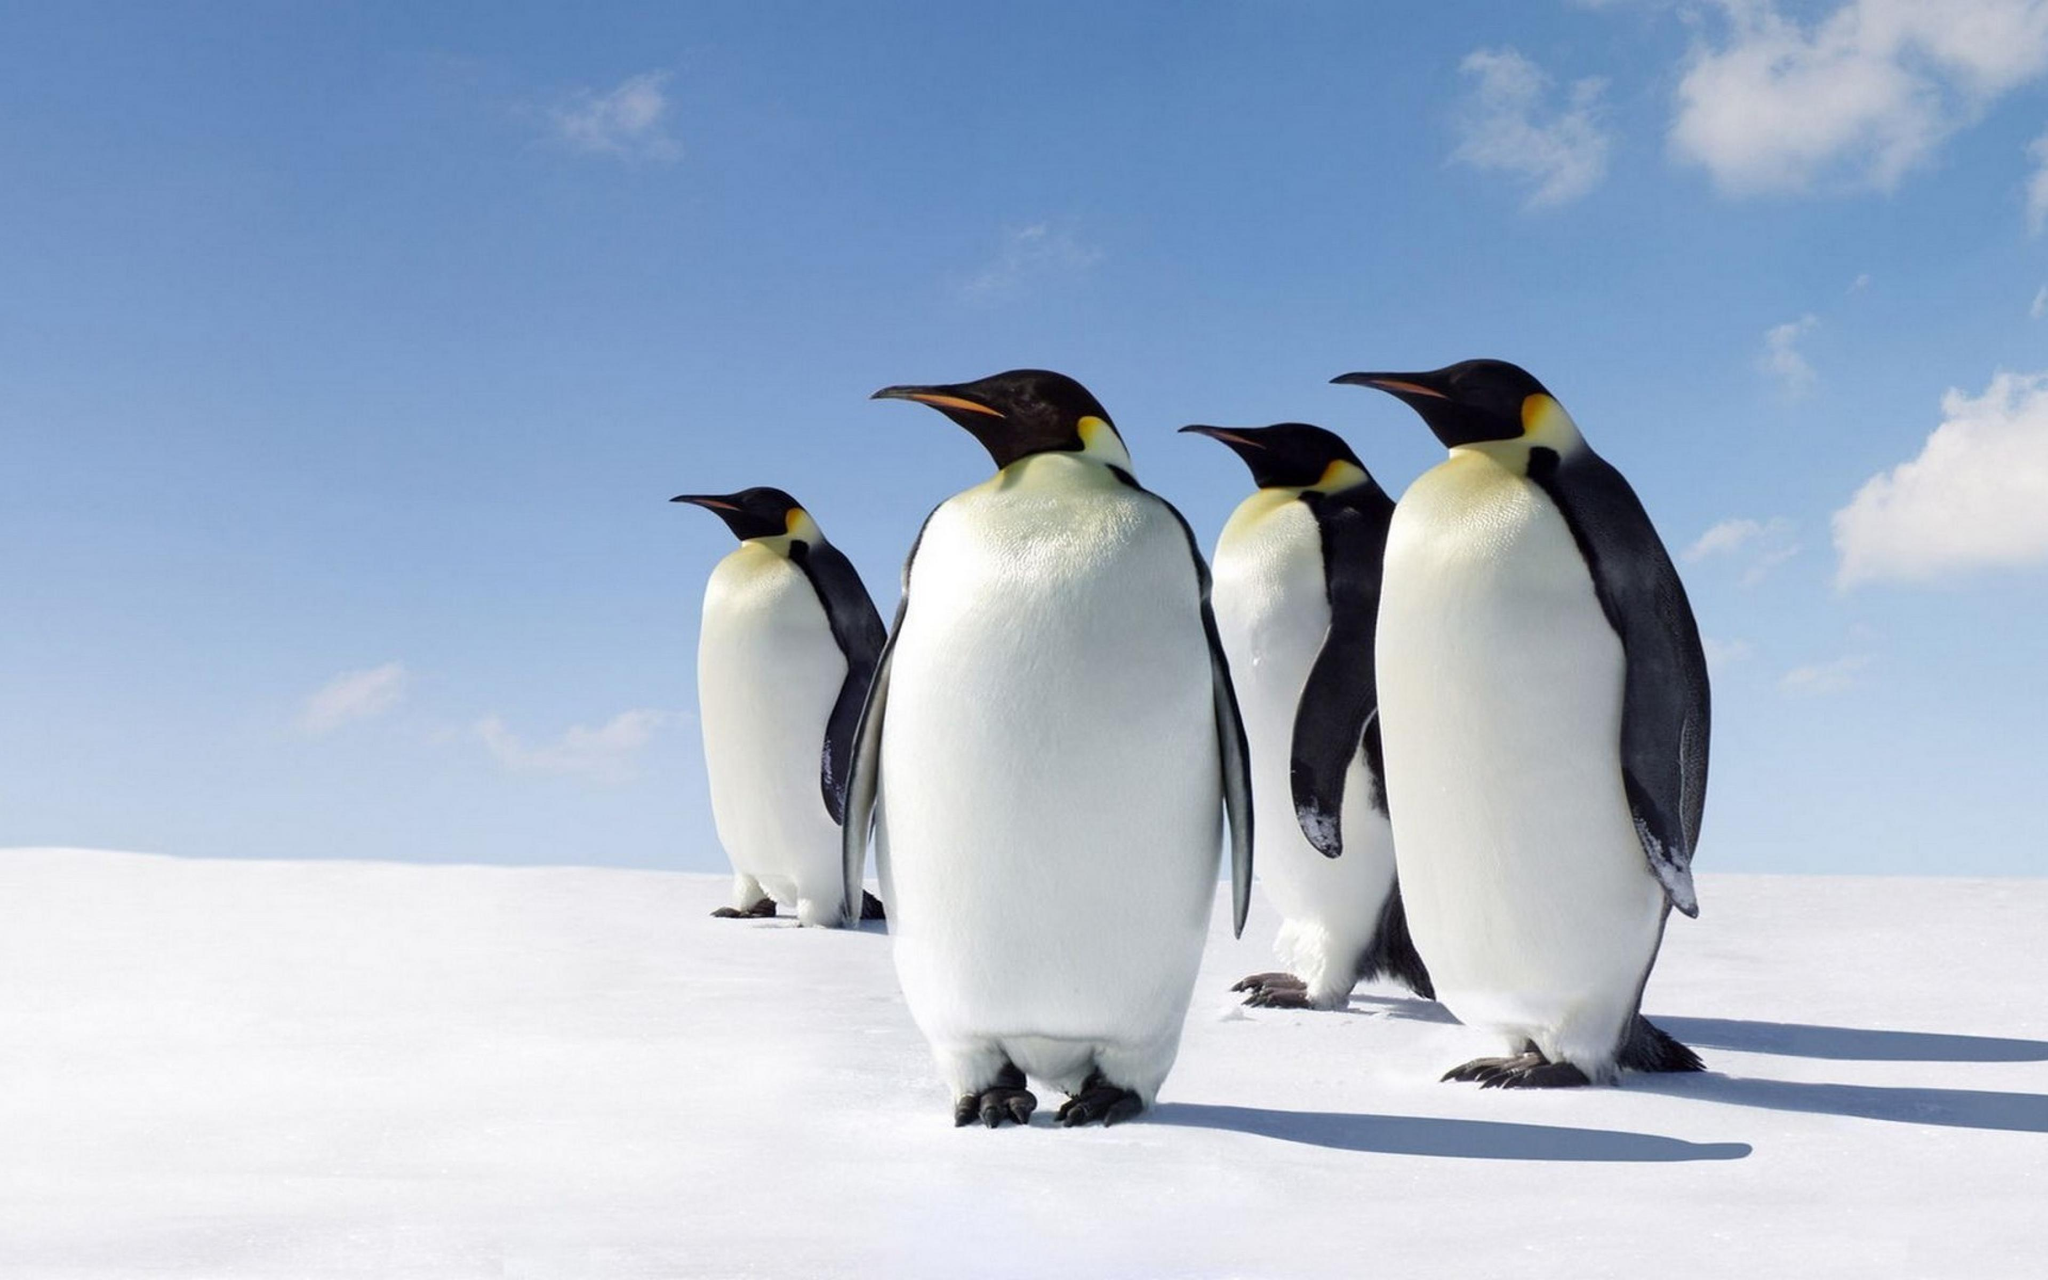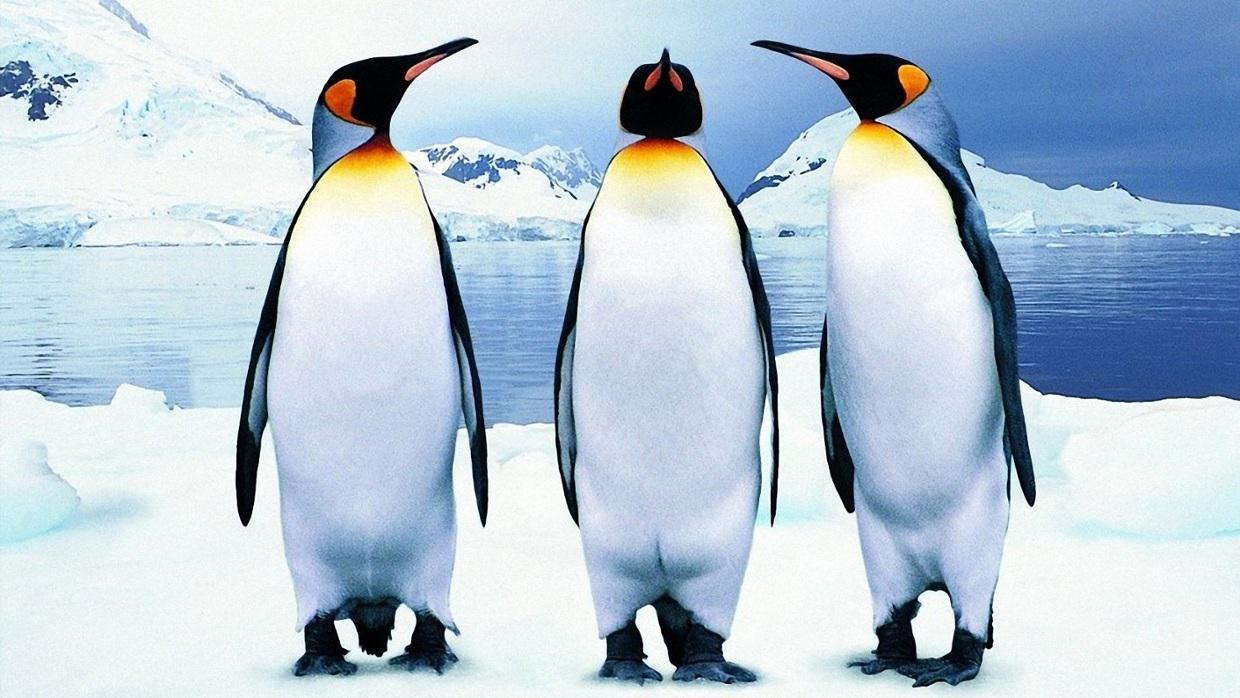The first image is the image on the left, the second image is the image on the right. For the images displayed, is the sentence "In one image there are at least one penguin standing on rock." factually correct? Answer yes or no. No. The first image is the image on the left, the second image is the image on the right. For the images shown, is this caption "There are exactly two penguins." true? Answer yes or no. No. 